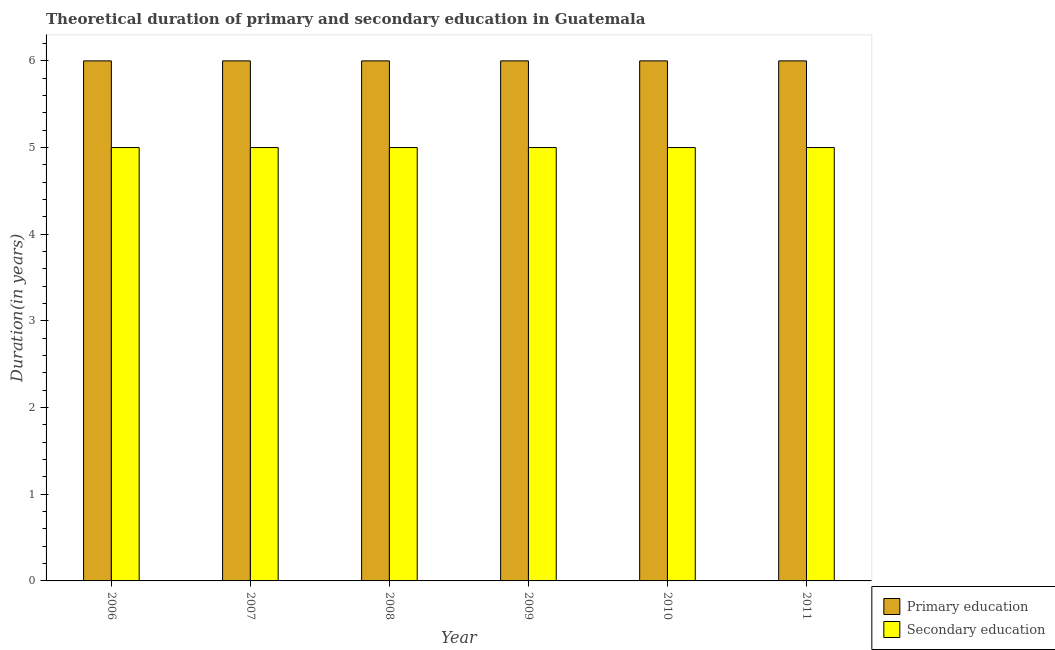How many different coloured bars are there?
Your response must be concise. 2. How many bars are there on the 6th tick from the left?
Your response must be concise. 2. How many bars are there on the 1st tick from the right?
Offer a terse response. 2. What is the label of the 3rd group of bars from the left?
Your response must be concise. 2008. In how many cases, is the number of bars for a given year not equal to the number of legend labels?
Keep it short and to the point. 0. What is the duration of secondary education in 2007?
Offer a very short reply. 5. In which year was the duration of secondary education maximum?
Keep it short and to the point. 2006. In which year was the duration of primary education minimum?
Give a very brief answer. 2006. What is the total duration of primary education in the graph?
Provide a succinct answer. 36. What is the difference between the duration of secondary education in 2006 and that in 2010?
Your answer should be compact. 0. What is the average duration of primary education per year?
Offer a very short reply. 6. In the year 2007, what is the difference between the duration of primary education and duration of secondary education?
Make the answer very short. 0. What is the ratio of the duration of secondary education in 2007 to that in 2010?
Ensure brevity in your answer.  1. Is the duration of primary education in 2007 less than that in 2011?
Ensure brevity in your answer.  No. What is the difference between the highest and the second highest duration of primary education?
Your answer should be compact. 0. What is the difference between the highest and the lowest duration of primary education?
Offer a terse response. 0. In how many years, is the duration of secondary education greater than the average duration of secondary education taken over all years?
Your response must be concise. 0. Is the sum of the duration of secondary education in 2007 and 2011 greater than the maximum duration of primary education across all years?
Give a very brief answer. Yes. What does the 1st bar from the right in 2010 represents?
Give a very brief answer. Secondary education. How many bars are there?
Ensure brevity in your answer.  12. Are all the bars in the graph horizontal?
Ensure brevity in your answer.  No. What is the difference between two consecutive major ticks on the Y-axis?
Provide a short and direct response. 1. Does the graph contain any zero values?
Your answer should be very brief. No. How are the legend labels stacked?
Offer a very short reply. Vertical. What is the title of the graph?
Provide a succinct answer. Theoretical duration of primary and secondary education in Guatemala. What is the label or title of the Y-axis?
Offer a very short reply. Duration(in years). What is the Duration(in years) in Primary education in 2007?
Provide a succinct answer. 6. What is the Duration(in years) of Secondary education in 2008?
Keep it short and to the point. 5. What is the Duration(in years) of Secondary education in 2010?
Keep it short and to the point. 5. What is the Duration(in years) in Primary education in 2011?
Offer a very short reply. 6. What is the Duration(in years) in Secondary education in 2011?
Your answer should be very brief. 5. Across all years, what is the minimum Duration(in years) in Primary education?
Your answer should be compact. 6. Across all years, what is the minimum Duration(in years) in Secondary education?
Your response must be concise. 5. What is the total Duration(in years) of Primary education in the graph?
Give a very brief answer. 36. What is the difference between the Duration(in years) in Secondary education in 2006 and that in 2007?
Give a very brief answer. 0. What is the difference between the Duration(in years) of Primary education in 2006 and that in 2009?
Make the answer very short. 0. What is the difference between the Duration(in years) in Secondary education in 2006 and that in 2009?
Give a very brief answer. 0. What is the difference between the Duration(in years) of Primary education in 2007 and that in 2010?
Offer a terse response. 0. What is the difference between the Duration(in years) of Primary education in 2008 and that in 2009?
Keep it short and to the point. 0. What is the difference between the Duration(in years) of Secondary education in 2008 and that in 2009?
Keep it short and to the point. 0. What is the difference between the Duration(in years) in Primary education in 2008 and that in 2010?
Your answer should be compact. 0. What is the difference between the Duration(in years) in Secondary education in 2008 and that in 2011?
Provide a short and direct response. 0. What is the difference between the Duration(in years) in Secondary education in 2009 and that in 2010?
Make the answer very short. 0. What is the difference between the Duration(in years) of Secondary education in 2010 and that in 2011?
Make the answer very short. 0. What is the difference between the Duration(in years) of Primary education in 2006 and the Duration(in years) of Secondary education in 2007?
Give a very brief answer. 1. What is the difference between the Duration(in years) in Primary education in 2006 and the Duration(in years) in Secondary education in 2008?
Your answer should be compact. 1. What is the difference between the Duration(in years) in Primary education in 2006 and the Duration(in years) in Secondary education in 2011?
Give a very brief answer. 1. What is the difference between the Duration(in years) of Primary education in 2008 and the Duration(in years) of Secondary education in 2011?
Keep it short and to the point. 1. What is the difference between the Duration(in years) in Primary education in 2009 and the Duration(in years) in Secondary education in 2010?
Offer a terse response. 1. What is the average Duration(in years) in Secondary education per year?
Your response must be concise. 5. In the year 2008, what is the difference between the Duration(in years) in Primary education and Duration(in years) in Secondary education?
Make the answer very short. 1. In the year 2010, what is the difference between the Duration(in years) of Primary education and Duration(in years) of Secondary education?
Keep it short and to the point. 1. In the year 2011, what is the difference between the Duration(in years) of Primary education and Duration(in years) of Secondary education?
Your response must be concise. 1. What is the ratio of the Duration(in years) of Primary education in 2006 to that in 2007?
Ensure brevity in your answer.  1. What is the ratio of the Duration(in years) in Secondary education in 2006 to that in 2008?
Provide a succinct answer. 1. What is the ratio of the Duration(in years) in Secondary education in 2006 to that in 2009?
Provide a short and direct response. 1. What is the ratio of the Duration(in years) of Primary education in 2006 to that in 2010?
Keep it short and to the point. 1. What is the ratio of the Duration(in years) in Secondary education in 2006 to that in 2010?
Your answer should be compact. 1. What is the ratio of the Duration(in years) of Primary education in 2007 to that in 2008?
Your response must be concise. 1. What is the ratio of the Duration(in years) of Secondary education in 2007 to that in 2008?
Give a very brief answer. 1. What is the ratio of the Duration(in years) in Secondary education in 2007 to that in 2009?
Offer a very short reply. 1. What is the ratio of the Duration(in years) in Primary education in 2007 to that in 2010?
Provide a short and direct response. 1. What is the ratio of the Duration(in years) in Primary education in 2007 to that in 2011?
Your answer should be compact. 1. What is the ratio of the Duration(in years) of Primary education in 2008 to that in 2009?
Provide a short and direct response. 1. What is the ratio of the Duration(in years) of Primary education in 2008 to that in 2010?
Your answer should be very brief. 1. What is the ratio of the Duration(in years) in Secondary education in 2008 to that in 2010?
Keep it short and to the point. 1. What is the ratio of the Duration(in years) of Primary education in 2008 to that in 2011?
Keep it short and to the point. 1. What is the ratio of the Duration(in years) of Primary education in 2009 to that in 2010?
Provide a short and direct response. 1. What is the ratio of the Duration(in years) in Secondary education in 2009 to that in 2010?
Your answer should be compact. 1. What is the ratio of the Duration(in years) in Secondary education in 2009 to that in 2011?
Your answer should be very brief. 1. What is the ratio of the Duration(in years) of Primary education in 2010 to that in 2011?
Provide a short and direct response. 1. What is the difference between the highest and the second highest Duration(in years) in Primary education?
Make the answer very short. 0. What is the difference between the highest and the lowest Duration(in years) in Primary education?
Your answer should be compact. 0. 